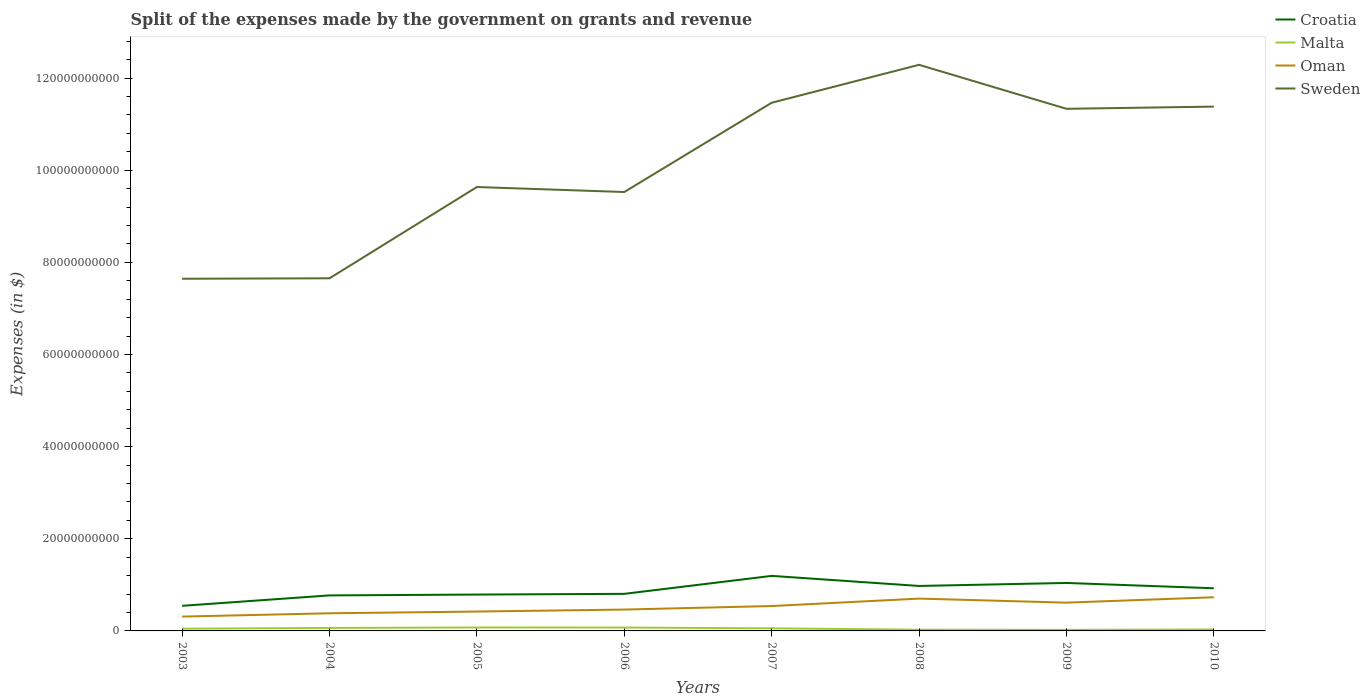How many different coloured lines are there?
Offer a very short reply. 4. Is the number of lines equal to the number of legend labels?
Ensure brevity in your answer.  Yes. Across all years, what is the maximum expenses made by the government on grants and revenue in Sweden?
Your answer should be very brief. 7.64e+1. In which year was the expenses made by the government on grants and revenue in Sweden maximum?
Offer a terse response. 2003. What is the total expenses made by the government on grants and revenue in Sweden in the graph?
Keep it short and to the point. -3.68e+1. What is the difference between the highest and the second highest expenses made by the government on grants and revenue in Croatia?
Keep it short and to the point. 6.50e+09. What is the difference between the highest and the lowest expenses made by the government on grants and revenue in Malta?
Make the answer very short. 4. How many years are there in the graph?
Provide a succinct answer. 8. Are the values on the major ticks of Y-axis written in scientific E-notation?
Provide a short and direct response. No. Does the graph contain any zero values?
Offer a terse response. No. Where does the legend appear in the graph?
Provide a short and direct response. Top right. How many legend labels are there?
Your response must be concise. 4. How are the legend labels stacked?
Your answer should be compact. Vertical. What is the title of the graph?
Your answer should be compact. Split of the expenses made by the government on grants and revenue. What is the label or title of the X-axis?
Offer a very short reply. Years. What is the label or title of the Y-axis?
Keep it short and to the point. Expenses (in $). What is the Expenses (in $) of Croatia in 2003?
Offer a terse response. 5.45e+09. What is the Expenses (in $) of Malta in 2003?
Make the answer very short. 4.88e+08. What is the Expenses (in $) of Oman in 2003?
Give a very brief answer. 3.11e+09. What is the Expenses (in $) of Sweden in 2003?
Your response must be concise. 7.64e+1. What is the Expenses (in $) of Croatia in 2004?
Your answer should be very brief. 7.71e+09. What is the Expenses (in $) in Malta in 2004?
Give a very brief answer. 6.48e+08. What is the Expenses (in $) in Oman in 2004?
Make the answer very short. 3.83e+09. What is the Expenses (in $) in Sweden in 2004?
Offer a terse response. 7.65e+1. What is the Expenses (in $) of Croatia in 2005?
Offer a very short reply. 7.89e+09. What is the Expenses (in $) in Malta in 2005?
Offer a very short reply. 7.45e+08. What is the Expenses (in $) of Oman in 2005?
Give a very brief answer. 4.21e+09. What is the Expenses (in $) in Sweden in 2005?
Offer a very short reply. 9.64e+1. What is the Expenses (in $) in Croatia in 2006?
Offer a terse response. 8.05e+09. What is the Expenses (in $) in Malta in 2006?
Offer a terse response. 7.33e+08. What is the Expenses (in $) in Oman in 2006?
Make the answer very short. 4.63e+09. What is the Expenses (in $) in Sweden in 2006?
Offer a very short reply. 9.53e+1. What is the Expenses (in $) of Croatia in 2007?
Provide a short and direct response. 1.19e+1. What is the Expenses (in $) of Malta in 2007?
Your answer should be compact. 5.64e+08. What is the Expenses (in $) in Oman in 2007?
Provide a succinct answer. 5.40e+09. What is the Expenses (in $) in Sweden in 2007?
Your response must be concise. 1.15e+11. What is the Expenses (in $) in Croatia in 2008?
Keep it short and to the point. 9.76e+09. What is the Expenses (in $) in Malta in 2008?
Ensure brevity in your answer.  2.65e+08. What is the Expenses (in $) of Oman in 2008?
Your response must be concise. 7.02e+09. What is the Expenses (in $) in Sweden in 2008?
Your answer should be very brief. 1.23e+11. What is the Expenses (in $) in Croatia in 2009?
Your response must be concise. 1.04e+1. What is the Expenses (in $) in Malta in 2009?
Offer a very short reply. 2.36e+08. What is the Expenses (in $) of Oman in 2009?
Your answer should be very brief. 6.14e+09. What is the Expenses (in $) in Sweden in 2009?
Provide a succinct answer. 1.13e+11. What is the Expenses (in $) of Croatia in 2010?
Provide a succinct answer. 9.26e+09. What is the Expenses (in $) in Malta in 2010?
Provide a succinct answer. 3.06e+08. What is the Expenses (in $) of Oman in 2010?
Offer a terse response. 7.31e+09. What is the Expenses (in $) in Sweden in 2010?
Offer a very short reply. 1.14e+11. Across all years, what is the maximum Expenses (in $) in Croatia?
Give a very brief answer. 1.19e+1. Across all years, what is the maximum Expenses (in $) in Malta?
Your answer should be compact. 7.45e+08. Across all years, what is the maximum Expenses (in $) of Oman?
Your answer should be very brief. 7.31e+09. Across all years, what is the maximum Expenses (in $) in Sweden?
Your response must be concise. 1.23e+11. Across all years, what is the minimum Expenses (in $) in Croatia?
Provide a short and direct response. 5.45e+09. Across all years, what is the minimum Expenses (in $) of Malta?
Ensure brevity in your answer.  2.36e+08. Across all years, what is the minimum Expenses (in $) of Oman?
Your answer should be very brief. 3.11e+09. Across all years, what is the minimum Expenses (in $) of Sweden?
Make the answer very short. 7.64e+1. What is the total Expenses (in $) in Croatia in the graph?
Offer a very short reply. 7.05e+1. What is the total Expenses (in $) of Malta in the graph?
Offer a very short reply. 3.98e+09. What is the total Expenses (in $) of Oman in the graph?
Keep it short and to the point. 4.16e+1. What is the total Expenses (in $) of Sweden in the graph?
Ensure brevity in your answer.  8.09e+11. What is the difference between the Expenses (in $) of Croatia in 2003 and that in 2004?
Your answer should be very brief. -2.26e+09. What is the difference between the Expenses (in $) of Malta in 2003 and that in 2004?
Offer a very short reply. -1.61e+08. What is the difference between the Expenses (in $) of Oman in 2003 and that in 2004?
Keep it short and to the point. -7.14e+08. What is the difference between the Expenses (in $) in Sweden in 2003 and that in 2004?
Give a very brief answer. -9.60e+07. What is the difference between the Expenses (in $) in Croatia in 2003 and that in 2005?
Give a very brief answer. -2.44e+09. What is the difference between the Expenses (in $) of Malta in 2003 and that in 2005?
Keep it short and to the point. -2.57e+08. What is the difference between the Expenses (in $) of Oman in 2003 and that in 2005?
Give a very brief answer. -1.09e+09. What is the difference between the Expenses (in $) in Sweden in 2003 and that in 2005?
Give a very brief answer. -1.99e+1. What is the difference between the Expenses (in $) of Croatia in 2003 and that in 2006?
Offer a terse response. -2.60e+09. What is the difference between the Expenses (in $) in Malta in 2003 and that in 2006?
Keep it short and to the point. -2.45e+08. What is the difference between the Expenses (in $) in Oman in 2003 and that in 2006?
Ensure brevity in your answer.  -1.52e+09. What is the difference between the Expenses (in $) of Sweden in 2003 and that in 2006?
Give a very brief answer. -1.88e+1. What is the difference between the Expenses (in $) of Croatia in 2003 and that in 2007?
Ensure brevity in your answer.  -6.50e+09. What is the difference between the Expenses (in $) in Malta in 2003 and that in 2007?
Make the answer very short. -7.63e+07. What is the difference between the Expenses (in $) of Oman in 2003 and that in 2007?
Your response must be concise. -2.29e+09. What is the difference between the Expenses (in $) in Sweden in 2003 and that in 2007?
Give a very brief answer. -3.82e+1. What is the difference between the Expenses (in $) of Croatia in 2003 and that in 2008?
Ensure brevity in your answer.  -4.31e+09. What is the difference between the Expenses (in $) in Malta in 2003 and that in 2008?
Your answer should be very brief. 2.23e+08. What is the difference between the Expenses (in $) in Oman in 2003 and that in 2008?
Your answer should be very brief. -3.90e+09. What is the difference between the Expenses (in $) of Sweden in 2003 and that in 2008?
Provide a succinct answer. -4.64e+1. What is the difference between the Expenses (in $) in Croatia in 2003 and that in 2009?
Make the answer very short. -4.96e+09. What is the difference between the Expenses (in $) of Malta in 2003 and that in 2009?
Provide a short and direct response. 2.52e+08. What is the difference between the Expenses (in $) of Oman in 2003 and that in 2009?
Your answer should be compact. -3.02e+09. What is the difference between the Expenses (in $) in Sweden in 2003 and that in 2009?
Ensure brevity in your answer.  -3.69e+1. What is the difference between the Expenses (in $) of Croatia in 2003 and that in 2010?
Offer a very short reply. -3.81e+09. What is the difference between the Expenses (in $) in Malta in 2003 and that in 2010?
Provide a succinct answer. 1.82e+08. What is the difference between the Expenses (in $) of Oman in 2003 and that in 2010?
Provide a short and direct response. -4.19e+09. What is the difference between the Expenses (in $) of Sweden in 2003 and that in 2010?
Provide a short and direct response. -3.74e+1. What is the difference between the Expenses (in $) in Croatia in 2004 and that in 2005?
Your answer should be compact. -1.84e+08. What is the difference between the Expenses (in $) in Malta in 2004 and that in 2005?
Make the answer very short. -9.64e+07. What is the difference between the Expenses (in $) of Oman in 2004 and that in 2005?
Provide a succinct answer. -3.76e+08. What is the difference between the Expenses (in $) in Sweden in 2004 and that in 2005?
Make the answer very short. -1.98e+1. What is the difference between the Expenses (in $) of Croatia in 2004 and that in 2006?
Keep it short and to the point. -3.39e+08. What is the difference between the Expenses (in $) in Malta in 2004 and that in 2006?
Offer a very short reply. -8.45e+07. What is the difference between the Expenses (in $) in Oman in 2004 and that in 2006?
Give a very brief answer. -8.06e+08. What is the difference between the Expenses (in $) of Sweden in 2004 and that in 2006?
Your answer should be compact. -1.87e+1. What is the difference between the Expenses (in $) of Croatia in 2004 and that in 2007?
Your answer should be very brief. -4.24e+09. What is the difference between the Expenses (in $) of Malta in 2004 and that in 2007?
Keep it short and to the point. 8.43e+07. What is the difference between the Expenses (in $) of Oman in 2004 and that in 2007?
Offer a terse response. -1.57e+09. What is the difference between the Expenses (in $) in Sweden in 2004 and that in 2007?
Your response must be concise. -3.81e+1. What is the difference between the Expenses (in $) in Croatia in 2004 and that in 2008?
Provide a short and direct response. -2.05e+09. What is the difference between the Expenses (in $) in Malta in 2004 and that in 2008?
Provide a short and direct response. 3.84e+08. What is the difference between the Expenses (in $) of Oman in 2004 and that in 2008?
Ensure brevity in your answer.  -3.19e+09. What is the difference between the Expenses (in $) in Sweden in 2004 and that in 2008?
Offer a terse response. -4.63e+1. What is the difference between the Expenses (in $) in Croatia in 2004 and that in 2009?
Provide a succinct answer. -2.71e+09. What is the difference between the Expenses (in $) in Malta in 2004 and that in 2009?
Your response must be concise. 4.12e+08. What is the difference between the Expenses (in $) in Oman in 2004 and that in 2009?
Your answer should be compact. -2.31e+09. What is the difference between the Expenses (in $) in Sweden in 2004 and that in 2009?
Ensure brevity in your answer.  -3.68e+1. What is the difference between the Expenses (in $) of Croatia in 2004 and that in 2010?
Offer a very short reply. -1.55e+09. What is the difference between the Expenses (in $) of Malta in 2004 and that in 2010?
Give a very brief answer. 3.43e+08. What is the difference between the Expenses (in $) of Oman in 2004 and that in 2010?
Provide a short and direct response. -3.48e+09. What is the difference between the Expenses (in $) in Sweden in 2004 and that in 2010?
Your response must be concise. -3.73e+1. What is the difference between the Expenses (in $) of Croatia in 2005 and that in 2006?
Keep it short and to the point. -1.55e+08. What is the difference between the Expenses (in $) of Malta in 2005 and that in 2006?
Make the answer very short. 1.19e+07. What is the difference between the Expenses (in $) of Oman in 2005 and that in 2006?
Make the answer very short. -4.30e+08. What is the difference between the Expenses (in $) in Sweden in 2005 and that in 2006?
Your answer should be very brief. 1.08e+09. What is the difference between the Expenses (in $) of Croatia in 2005 and that in 2007?
Keep it short and to the point. -4.06e+09. What is the difference between the Expenses (in $) of Malta in 2005 and that in 2007?
Your answer should be very brief. 1.81e+08. What is the difference between the Expenses (in $) of Oman in 2005 and that in 2007?
Give a very brief answer. -1.20e+09. What is the difference between the Expenses (in $) in Sweden in 2005 and that in 2007?
Provide a short and direct response. -1.83e+1. What is the difference between the Expenses (in $) in Croatia in 2005 and that in 2008?
Ensure brevity in your answer.  -1.87e+09. What is the difference between the Expenses (in $) in Malta in 2005 and that in 2008?
Make the answer very short. 4.80e+08. What is the difference between the Expenses (in $) of Oman in 2005 and that in 2008?
Give a very brief answer. -2.81e+09. What is the difference between the Expenses (in $) in Sweden in 2005 and that in 2008?
Offer a very short reply. -2.65e+1. What is the difference between the Expenses (in $) in Croatia in 2005 and that in 2009?
Your response must be concise. -2.52e+09. What is the difference between the Expenses (in $) in Malta in 2005 and that in 2009?
Make the answer very short. 5.09e+08. What is the difference between the Expenses (in $) in Oman in 2005 and that in 2009?
Your answer should be compact. -1.93e+09. What is the difference between the Expenses (in $) in Sweden in 2005 and that in 2009?
Make the answer very short. -1.70e+1. What is the difference between the Expenses (in $) in Croatia in 2005 and that in 2010?
Make the answer very short. -1.37e+09. What is the difference between the Expenses (in $) of Malta in 2005 and that in 2010?
Your response must be concise. 4.39e+08. What is the difference between the Expenses (in $) of Oman in 2005 and that in 2010?
Make the answer very short. -3.10e+09. What is the difference between the Expenses (in $) of Sweden in 2005 and that in 2010?
Your response must be concise. -1.75e+1. What is the difference between the Expenses (in $) in Croatia in 2006 and that in 2007?
Make the answer very short. -3.90e+09. What is the difference between the Expenses (in $) in Malta in 2006 and that in 2007?
Provide a short and direct response. 1.69e+08. What is the difference between the Expenses (in $) in Oman in 2006 and that in 2007?
Give a very brief answer. -7.66e+08. What is the difference between the Expenses (in $) of Sweden in 2006 and that in 2007?
Your answer should be compact. -1.94e+1. What is the difference between the Expenses (in $) of Croatia in 2006 and that in 2008?
Provide a short and direct response. -1.71e+09. What is the difference between the Expenses (in $) of Malta in 2006 and that in 2008?
Make the answer very short. 4.68e+08. What is the difference between the Expenses (in $) of Oman in 2006 and that in 2008?
Ensure brevity in your answer.  -2.38e+09. What is the difference between the Expenses (in $) of Sweden in 2006 and that in 2008?
Your response must be concise. -2.76e+1. What is the difference between the Expenses (in $) of Croatia in 2006 and that in 2009?
Provide a succinct answer. -2.37e+09. What is the difference between the Expenses (in $) of Malta in 2006 and that in 2009?
Keep it short and to the point. 4.97e+08. What is the difference between the Expenses (in $) of Oman in 2006 and that in 2009?
Provide a short and direct response. -1.50e+09. What is the difference between the Expenses (in $) of Sweden in 2006 and that in 2009?
Ensure brevity in your answer.  -1.81e+1. What is the difference between the Expenses (in $) in Croatia in 2006 and that in 2010?
Your response must be concise. -1.22e+09. What is the difference between the Expenses (in $) of Malta in 2006 and that in 2010?
Your answer should be compact. 4.27e+08. What is the difference between the Expenses (in $) of Oman in 2006 and that in 2010?
Provide a succinct answer. -2.67e+09. What is the difference between the Expenses (in $) of Sweden in 2006 and that in 2010?
Keep it short and to the point. -1.85e+1. What is the difference between the Expenses (in $) in Croatia in 2007 and that in 2008?
Provide a succinct answer. 2.19e+09. What is the difference between the Expenses (in $) in Malta in 2007 and that in 2008?
Your answer should be compact. 3.00e+08. What is the difference between the Expenses (in $) in Oman in 2007 and that in 2008?
Provide a succinct answer. -1.62e+09. What is the difference between the Expenses (in $) in Sweden in 2007 and that in 2008?
Your answer should be very brief. -8.23e+09. What is the difference between the Expenses (in $) in Croatia in 2007 and that in 2009?
Offer a very short reply. 1.53e+09. What is the difference between the Expenses (in $) in Malta in 2007 and that in 2009?
Offer a terse response. 3.28e+08. What is the difference between the Expenses (in $) of Oman in 2007 and that in 2009?
Provide a succinct answer. -7.37e+08. What is the difference between the Expenses (in $) of Sweden in 2007 and that in 2009?
Provide a succinct answer. 1.31e+09. What is the difference between the Expenses (in $) of Croatia in 2007 and that in 2010?
Provide a succinct answer. 2.69e+09. What is the difference between the Expenses (in $) of Malta in 2007 and that in 2010?
Provide a short and direct response. 2.58e+08. What is the difference between the Expenses (in $) in Oman in 2007 and that in 2010?
Keep it short and to the point. -1.90e+09. What is the difference between the Expenses (in $) in Sweden in 2007 and that in 2010?
Offer a terse response. 8.37e+08. What is the difference between the Expenses (in $) in Croatia in 2008 and that in 2009?
Your response must be concise. -6.52e+08. What is the difference between the Expenses (in $) of Malta in 2008 and that in 2009?
Your answer should be compact. 2.85e+07. What is the difference between the Expenses (in $) in Oman in 2008 and that in 2009?
Offer a terse response. 8.79e+08. What is the difference between the Expenses (in $) in Sweden in 2008 and that in 2009?
Make the answer very short. 9.54e+09. What is the difference between the Expenses (in $) in Croatia in 2008 and that in 2010?
Your answer should be compact. 4.98e+08. What is the difference between the Expenses (in $) in Malta in 2008 and that in 2010?
Keep it short and to the point. -4.12e+07. What is the difference between the Expenses (in $) in Oman in 2008 and that in 2010?
Make the answer very short. -2.88e+08. What is the difference between the Expenses (in $) in Sweden in 2008 and that in 2010?
Offer a very short reply. 9.07e+09. What is the difference between the Expenses (in $) in Croatia in 2009 and that in 2010?
Your response must be concise. 1.15e+09. What is the difference between the Expenses (in $) in Malta in 2009 and that in 2010?
Offer a very short reply. -6.97e+07. What is the difference between the Expenses (in $) of Oman in 2009 and that in 2010?
Offer a very short reply. -1.17e+09. What is the difference between the Expenses (in $) of Sweden in 2009 and that in 2010?
Offer a very short reply. -4.74e+08. What is the difference between the Expenses (in $) in Croatia in 2003 and the Expenses (in $) in Malta in 2004?
Keep it short and to the point. 4.80e+09. What is the difference between the Expenses (in $) in Croatia in 2003 and the Expenses (in $) in Oman in 2004?
Provide a short and direct response. 1.62e+09. What is the difference between the Expenses (in $) of Croatia in 2003 and the Expenses (in $) of Sweden in 2004?
Ensure brevity in your answer.  -7.11e+1. What is the difference between the Expenses (in $) in Malta in 2003 and the Expenses (in $) in Oman in 2004?
Your answer should be very brief. -3.34e+09. What is the difference between the Expenses (in $) of Malta in 2003 and the Expenses (in $) of Sweden in 2004?
Offer a very short reply. -7.61e+1. What is the difference between the Expenses (in $) of Oman in 2003 and the Expenses (in $) of Sweden in 2004?
Provide a short and direct response. -7.34e+1. What is the difference between the Expenses (in $) in Croatia in 2003 and the Expenses (in $) in Malta in 2005?
Make the answer very short. 4.70e+09. What is the difference between the Expenses (in $) of Croatia in 2003 and the Expenses (in $) of Oman in 2005?
Give a very brief answer. 1.24e+09. What is the difference between the Expenses (in $) in Croatia in 2003 and the Expenses (in $) in Sweden in 2005?
Your answer should be very brief. -9.09e+1. What is the difference between the Expenses (in $) in Malta in 2003 and the Expenses (in $) in Oman in 2005?
Your answer should be compact. -3.72e+09. What is the difference between the Expenses (in $) in Malta in 2003 and the Expenses (in $) in Sweden in 2005?
Offer a very short reply. -9.59e+1. What is the difference between the Expenses (in $) of Oman in 2003 and the Expenses (in $) of Sweden in 2005?
Your answer should be very brief. -9.32e+1. What is the difference between the Expenses (in $) in Croatia in 2003 and the Expenses (in $) in Malta in 2006?
Provide a short and direct response. 4.72e+09. What is the difference between the Expenses (in $) of Croatia in 2003 and the Expenses (in $) of Oman in 2006?
Keep it short and to the point. 8.15e+08. What is the difference between the Expenses (in $) of Croatia in 2003 and the Expenses (in $) of Sweden in 2006?
Ensure brevity in your answer.  -8.98e+1. What is the difference between the Expenses (in $) of Malta in 2003 and the Expenses (in $) of Oman in 2006?
Offer a terse response. -4.15e+09. What is the difference between the Expenses (in $) of Malta in 2003 and the Expenses (in $) of Sweden in 2006?
Provide a short and direct response. -9.48e+1. What is the difference between the Expenses (in $) in Oman in 2003 and the Expenses (in $) in Sweden in 2006?
Make the answer very short. -9.22e+1. What is the difference between the Expenses (in $) of Croatia in 2003 and the Expenses (in $) of Malta in 2007?
Your answer should be very brief. 4.89e+09. What is the difference between the Expenses (in $) of Croatia in 2003 and the Expenses (in $) of Oman in 2007?
Ensure brevity in your answer.  4.87e+07. What is the difference between the Expenses (in $) in Croatia in 2003 and the Expenses (in $) in Sweden in 2007?
Your answer should be compact. -1.09e+11. What is the difference between the Expenses (in $) of Malta in 2003 and the Expenses (in $) of Oman in 2007?
Ensure brevity in your answer.  -4.91e+09. What is the difference between the Expenses (in $) of Malta in 2003 and the Expenses (in $) of Sweden in 2007?
Provide a short and direct response. -1.14e+11. What is the difference between the Expenses (in $) of Oman in 2003 and the Expenses (in $) of Sweden in 2007?
Ensure brevity in your answer.  -1.12e+11. What is the difference between the Expenses (in $) of Croatia in 2003 and the Expenses (in $) of Malta in 2008?
Keep it short and to the point. 5.19e+09. What is the difference between the Expenses (in $) in Croatia in 2003 and the Expenses (in $) in Oman in 2008?
Make the answer very short. -1.57e+09. What is the difference between the Expenses (in $) of Croatia in 2003 and the Expenses (in $) of Sweden in 2008?
Provide a succinct answer. -1.17e+11. What is the difference between the Expenses (in $) of Malta in 2003 and the Expenses (in $) of Oman in 2008?
Your answer should be very brief. -6.53e+09. What is the difference between the Expenses (in $) of Malta in 2003 and the Expenses (in $) of Sweden in 2008?
Give a very brief answer. -1.22e+11. What is the difference between the Expenses (in $) of Oman in 2003 and the Expenses (in $) of Sweden in 2008?
Keep it short and to the point. -1.20e+11. What is the difference between the Expenses (in $) in Croatia in 2003 and the Expenses (in $) in Malta in 2009?
Your answer should be very brief. 5.21e+09. What is the difference between the Expenses (in $) in Croatia in 2003 and the Expenses (in $) in Oman in 2009?
Offer a terse response. -6.89e+08. What is the difference between the Expenses (in $) of Croatia in 2003 and the Expenses (in $) of Sweden in 2009?
Make the answer very short. -1.08e+11. What is the difference between the Expenses (in $) in Malta in 2003 and the Expenses (in $) in Oman in 2009?
Provide a succinct answer. -5.65e+09. What is the difference between the Expenses (in $) of Malta in 2003 and the Expenses (in $) of Sweden in 2009?
Your response must be concise. -1.13e+11. What is the difference between the Expenses (in $) in Oman in 2003 and the Expenses (in $) in Sweden in 2009?
Keep it short and to the point. -1.10e+11. What is the difference between the Expenses (in $) in Croatia in 2003 and the Expenses (in $) in Malta in 2010?
Give a very brief answer. 5.14e+09. What is the difference between the Expenses (in $) of Croatia in 2003 and the Expenses (in $) of Oman in 2010?
Offer a very short reply. -1.86e+09. What is the difference between the Expenses (in $) in Croatia in 2003 and the Expenses (in $) in Sweden in 2010?
Your answer should be very brief. -1.08e+11. What is the difference between the Expenses (in $) in Malta in 2003 and the Expenses (in $) in Oman in 2010?
Provide a succinct answer. -6.82e+09. What is the difference between the Expenses (in $) of Malta in 2003 and the Expenses (in $) of Sweden in 2010?
Offer a terse response. -1.13e+11. What is the difference between the Expenses (in $) of Oman in 2003 and the Expenses (in $) of Sweden in 2010?
Keep it short and to the point. -1.11e+11. What is the difference between the Expenses (in $) in Croatia in 2004 and the Expenses (in $) in Malta in 2005?
Your answer should be compact. 6.96e+09. What is the difference between the Expenses (in $) of Croatia in 2004 and the Expenses (in $) of Oman in 2005?
Offer a terse response. 3.50e+09. What is the difference between the Expenses (in $) in Croatia in 2004 and the Expenses (in $) in Sweden in 2005?
Provide a succinct answer. -8.86e+1. What is the difference between the Expenses (in $) in Malta in 2004 and the Expenses (in $) in Oman in 2005?
Offer a terse response. -3.56e+09. What is the difference between the Expenses (in $) in Malta in 2004 and the Expenses (in $) in Sweden in 2005?
Your response must be concise. -9.57e+1. What is the difference between the Expenses (in $) in Oman in 2004 and the Expenses (in $) in Sweden in 2005?
Your response must be concise. -9.25e+1. What is the difference between the Expenses (in $) of Croatia in 2004 and the Expenses (in $) of Malta in 2006?
Your answer should be very brief. 6.98e+09. What is the difference between the Expenses (in $) in Croatia in 2004 and the Expenses (in $) in Oman in 2006?
Provide a succinct answer. 3.07e+09. What is the difference between the Expenses (in $) in Croatia in 2004 and the Expenses (in $) in Sweden in 2006?
Give a very brief answer. -8.76e+1. What is the difference between the Expenses (in $) of Malta in 2004 and the Expenses (in $) of Oman in 2006?
Keep it short and to the point. -3.99e+09. What is the difference between the Expenses (in $) in Malta in 2004 and the Expenses (in $) in Sweden in 2006?
Your response must be concise. -9.46e+1. What is the difference between the Expenses (in $) of Oman in 2004 and the Expenses (in $) of Sweden in 2006?
Offer a terse response. -9.14e+1. What is the difference between the Expenses (in $) in Croatia in 2004 and the Expenses (in $) in Malta in 2007?
Provide a succinct answer. 7.14e+09. What is the difference between the Expenses (in $) in Croatia in 2004 and the Expenses (in $) in Oman in 2007?
Your answer should be very brief. 2.31e+09. What is the difference between the Expenses (in $) in Croatia in 2004 and the Expenses (in $) in Sweden in 2007?
Give a very brief answer. -1.07e+11. What is the difference between the Expenses (in $) of Malta in 2004 and the Expenses (in $) of Oman in 2007?
Your answer should be very brief. -4.75e+09. What is the difference between the Expenses (in $) in Malta in 2004 and the Expenses (in $) in Sweden in 2007?
Ensure brevity in your answer.  -1.14e+11. What is the difference between the Expenses (in $) in Oman in 2004 and the Expenses (in $) in Sweden in 2007?
Make the answer very short. -1.11e+11. What is the difference between the Expenses (in $) of Croatia in 2004 and the Expenses (in $) of Malta in 2008?
Provide a succinct answer. 7.44e+09. What is the difference between the Expenses (in $) in Croatia in 2004 and the Expenses (in $) in Oman in 2008?
Ensure brevity in your answer.  6.90e+08. What is the difference between the Expenses (in $) in Croatia in 2004 and the Expenses (in $) in Sweden in 2008?
Provide a succinct answer. -1.15e+11. What is the difference between the Expenses (in $) in Malta in 2004 and the Expenses (in $) in Oman in 2008?
Offer a very short reply. -6.37e+09. What is the difference between the Expenses (in $) in Malta in 2004 and the Expenses (in $) in Sweden in 2008?
Your response must be concise. -1.22e+11. What is the difference between the Expenses (in $) in Oman in 2004 and the Expenses (in $) in Sweden in 2008?
Your answer should be compact. -1.19e+11. What is the difference between the Expenses (in $) of Croatia in 2004 and the Expenses (in $) of Malta in 2009?
Give a very brief answer. 7.47e+09. What is the difference between the Expenses (in $) in Croatia in 2004 and the Expenses (in $) in Oman in 2009?
Offer a terse response. 1.57e+09. What is the difference between the Expenses (in $) of Croatia in 2004 and the Expenses (in $) of Sweden in 2009?
Keep it short and to the point. -1.06e+11. What is the difference between the Expenses (in $) of Malta in 2004 and the Expenses (in $) of Oman in 2009?
Ensure brevity in your answer.  -5.49e+09. What is the difference between the Expenses (in $) of Malta in 2004 and the Expenses (in $) of Sweden in 2009?
Provide a short and direct response. -1.13e+11. What is the difference between the Expenses (in $) of Oman in 2004 and the Expenses (in $) of Sweden in 2009?
Your response must be concise. -1.10e+11. What is the difference between the Expenses (in $) of Croatia in 2004 and the Expenses (in $) of Malta in 2010?
Give a very brief answer. 7.40e+09. What is the difference between the Expenses (in $) in Croatia in 2004 and the Expenses (in $) in Oman in 2010?
Keep it short and to the point. 4.03e+08. What is the difference between the Expenses (in $) in Croatia in 2004 and the Expenses (in $) in Sweden in 2010?
Your answer should be compact. -1.06e+11. What is the difference between the Expenses (in $) of Malta in 2004 and the Expenses (in $) of Oman in 2010?
Provide a short and direct response. -6.66e+09. What is the difference between the Expenses (in $) in Malta in 2004 and the Expenses (in $) in Sweden in 2010?
Give a very brief answer. -1.13e+11. What is the difference between the Expenses (in $) in Oman in 2004 and the Expenses (in $) in Sweden in 2010?
Keep it short and to the point. -1.10e+11. What is the difference between the Expenses (in $) in Croatia in 2005 and the Expenses (in $) in Malta in 2006?
Ensure brevity in your answer.  7.16e+09. What is the difference between the Expenses (in $) in Croatia in 2005 and the Expenses (in $) in Oman in 2006?
Provide a short and direct response. 3.26e+09. What is the difference between the Expenses (in $) of Croatia in 2005 and the Expenses (in $) of Sweden in 2006?
Your response must be concise. -8.74e+1. What is the difference between the Expenses (in $) of Malta in 2005 and the Expenses (in $) of Oman in 2006?
Make the answer very short. -3.89e+09. What is the difference between the Expenses (in $) of Malta in 2005 and the Expenses (in $) of Sweden in 2006?
Ensure brevity in your answer.  -9.45e+1. What is the difference between the Expenses (in $) of Oman in 2005 and the Expenses (in $) of Sweden in 2006?
Your answer should be very brief. -9.11e+1. What is the difference between the Expenses (in $) in Croatia in 2005 and the Expenses (in $) in Malta in 2007?
Give a very brief answer. 7.33e+09. What is the difference between the Expenses (in $) in Croatia in 2005 and the Expenses (in $) in Oman in 2007?
Give a very brief answer. 2.49e+09. What is the difference between the Expenses (in $) in Croatia in 2005 and the Expenses (in $) in Sweden in 2007?
Ensure brevity in your answer.  -1.07e+11. What is the difference between the Expenses (in $) of Malta in 2005 and the Expenses (in $) of Oman in 2007?
Offer a very short reply. -4.66e+09. What is the difference between the Expenses (in $) in Malta in 2005 and the Expenses (in $) in Sweden in 2007?
Offer a very short reply. -1.14e+11. What is the difference between the Expenses (in $) in Oman in 2005 and the Expenses (in $) in Sweden in 2007?
Your answer should be very brief. -1.10e+11. What is the difference between the Expenses (in $) of Croatia in 2005 and the Expenses (in $) of Malta in 2008?
Provide a succinct answer. 7.63e+09. What is the difference between the Expenses (in $) of Croatia in 2005 and the Expenses (in $) of Oman in 2008?
Keep it short and to the point. 8.74e+08. What is the difference between the Expenses (in $) in Croatia in 2005 and the Expenses (in $) in Sweden in 2008?
Your answer should be compact. -1.15e+11. What is the difference between the Expenses (in $) of Malta in 2005 and the Expenses (in $) of Oman in 2008?
Provide a succinct answer. -6.27e+09. What is the difference between the Expenses (in $) in Malta in 2005 and the Expenses (in $) in Sweden in 2008?
Ensure brevity in your answer.  -1.22e+11. What is the difference between the Expenses (in $) of Oman in 2005 and the Expenses (in $) of Sweden in 2008?
Keep it short and to the point. -1.19e+11. What is the difference between the Expenses (in $) in Croatia in 2005 and the Expenses (in $) in Malta in 2009?
Keep it short and to the point. 7.66e+09. What is the difference between the Expenses (in $) in Croatia in 2005 and the Expenses (in $) in Oman in 2009?
Make the answer very short. 1.75e+09. What is the difference between the Expenses (in $) of Croatia in 2005 and the Expenses (in $) of Sweden in 2009?
Your answer should be compact. -1.05e+11. What is the difference between the Expenses (in $) of Malta in 2005 and the Expenses (in $) of Oman in 2009?
Your response must be concise. -5.39e+09. What is the difference between the Expenses (in $) in Malta in 2005 and the Expenses (in $) in Sweden in 2009?
Your response must be concise. -1.13e+11. What is the difference between the Expenses (in $) in Oman in 2005 and the Expenses (in $) in Sweden in 2009?
Give a very brief answer. -1.09e+11. What is the difference between the Expenses (in $) in Croatia in 2005 and the Expenses (in $) in Malta in 2010?
Give a very brief answer. 7.59e+09. What is the difference between the Expenses (in $) of Croatia in 2005 and the Expenses (in $) of Oman in 2010?
Your response must be concise. 5.87e+08. What is the difference between the Expenses (in $) of Croatia in 2005 and the Expenses (in $) of Sweden in 2010?
Your response must be concise. -1.06e+11. What is the difference between the Expenses (in $) of Malta in 2005 and the Expenses (in $) of Oman in 2010?
Your answer should be very brief. -6.56e+09. What is the difference between the Expenses (in $) in Malta in 2005 and the Expenses (in $) in Sweden in 2010?
Your answer should be very brief. -1.13e+11. What is the difference between the Expenses (in $) of Oman in 2005 and the Expenses (in $) of Sweden in 2010?
Your response must be concise. -1.10e+11. What is the difference between the Expenses (in $) of Croatia in 2006 and the Expenses (in $) of Malta in 2007?
Give a very brief answer. 7.48e+09. What is the difference between the Expenses (in $) of Croatia in 2006 and the Expenses (in $) of Oman in 2007?
Offer a terse response. 2.65e+09. What is the difference between the Expenses (in $) of Croatia in 2006 and the Expenses (in $) of Sweden in 2007?
Make the answer very short. -1.07e+11. What is the difference between the Expenses (in $) of Malta in 2006 and the Expenses (in $) of Oman in 2007?
Your answer should be very brief. -4.67e+09. What is the difference between the Expenses (in $) of Malta in 2006 and the Expenses (in $) of Sweden in 2007?
Provide a succinct answer. -1.14e+11. What is the difference between the Expenses (in $) of Oman in 2006 and the Expenses (in $) of Sweden in 2007?
Your response must be concise. -1.10e+11. What is the difference between the Expenses (in $) in Croatia in 2006 and the Expenses (in $) in Malta in 2008?
Keep it short and to the point. 7.78e+09. What is the difference between the Expenses (in $) of Croatia in 2006 and the Expenses (in $) of Oman in 2008?
Your answer should be compact. 1.03e+09. What is the difference between the Expenses (in $) in Croatia in 2006 and the Expenses (in $) in Sweden in 2008?
Make the answer very short. -1.15e+11. What is the difference between the Expenses (in $) in Malta in 2006 and the Expenses (in $) in Oman in 2008?
Keep it short and to the point. -6.28e+09. What is the difference between the Expenses (in $) of Malta in 2006 and the Expenses (in $) of Sweden in 2008?
Ensure brevity in your answer.  -1.22e+11. What is the difference between the Expenses (in $) in Oman in 2006 and the Expenses (in $) in Sweden in 2008?
Keep it short and to the point. -1.18e+11. What is the difference between the Expenses (in $) in Croatia in 2006 and the Expenses (in $) in Malta in 2009?
Provide a succinct answer. 7.81e+09. What is the difference between the Expenses (in $) of Croatia in 2006 and the Expenses (in $) of Oman in 2009?
Your answer should be compact. 1.91e+09. What is the difference between the Expenses (in $) in Croatia in 2006 and the Expenses (in $) in Sweden in 2009?
Your response must be concise. -1.05e+11. What is the difference between the Expenses (in $) in Malta in 2006 and the Expenses (in $) in Oman in 2009?
Offer a very short reply. -5.41e+09. What is the difference between the Expenses (in $) in Malta in 2006 and the Expenses (in $) in Sweden in 2009?
Provide a short and direct response. -1.13e+11. What is the difference between the Expenses (in $) of Oman in 2006 and the Expenses (in $) of Sweden in 2009?
Keep it short and to the point. -1.09e+11. What is the difference between the Expenses (in $) in Croatia in 2006 and the Expenses (in $) in Malta in 2010?
Provide a succinct answer. 7.74e+09. What is the difference between the Expenses (in $) in Croatia in 2006 and the Expenses (in $) in Oman in 2010?
Give a very brief answer. 7.42e+08. What is the difference between the Expenses (in $) of Croatia in 2006 and the Expenses (in $) of Sweden in 2010?
Your response must be concise. -1.06e+11. What is the difference between the Expenses (in $) in Malta in 2006 and the Expenses (in $) in Oman in 2010?
Your response must be concise. -6.57e+09. What is the difference between the Expenses (in $) of Malta in 2006 and the Expenses (in $) of Sweden in 2010?
Your answer should be compact. -1.13e+11. What is the difference between the Expenses (in $) of Oman in 2006 and the Expenses (in $) of Sweden in 2010?
Provide a succinct answer. -1.09e+11. What is the difference between the Expenses (in $) of Croatia in 2007 and the Expenses (in $) of Malta in 2008?
Your answer should be compact. 1.17e+1. What is the difference between the Expenses (in $) in Croatia in 2007 and the Expenses (in $) in Oman in 2008?
Your answer should be very brief. 4.93e+09. What is the difference between the Expenses (in $) in Croatia in 2007 and the Expenses (in $) in Sweden in 2008?
Your answer should be very brief. -1.11e+11. What is the difference between the Expenses (in $) in Malta in 2007 and the Expenses (in $) in Oman in 2008?
Offer a terse response. -6.45e+09. What is the difference between the Expenses (in $) in Malta in 2007 and the Expenses (in $) in Sweden in 2008?
Keep it short and to the point. -1.22e+11. What is the difference between the Expenses (in $) of Oman in 2007 and the Expenses (in $) of Sweden in 2008?
Keep it short and to the point. -1.17e+11. What is the difference between the Expenses (in $) in Croatia in 2007 and the Expenses (in $) in Malta in 2009?
Offer a very short reply. 1.17e+1. What is the difference between the Expenses (in $) of Croatia in 2007 and the Expenses (in $) of Oman in 2009?
Ensure brevity in your answer.  5.81e+09. What is the difference between the Expenses (in $) of Croatia in 2007 and the Expenses (in $) of Sweden in 2009?
Offer a very short reply. -1.01e+11. What is the difference between the Expenses (in $) of Malta in 2007 and the Expenses (in $) of Oman in 2009?
Give a very brief answer. -5.57e+09. What is the difference between the Expenses (in $) in Malta in 2007 and the Expenses (in $) in Sweden in 2009?
Keep it short and to the point. -1.13e+11. What is the difference between the Expenses (in $) in Oman in 2007 and the Expenses (in $) in Sweden in 2009?
Provide a succinct answer. -1.08e+11. What is the difference between the Expenses (in $) in Croatia in 2007 and the Expenses (in $) in Malta in 2010?
Your answer should be very brief. 1.16e+1. What is the difference between the Expenses (in $) of Croatia in 2007 and the Expenses (in $) of Oman in 2010?
Give a very brief answer. 4.64e+09. What is the difference between the Expenses (in $) in Croatia in 2007 and the Expenses (in $) in Sweden in 2010?
Offer a very short reply. -1.02e+11. What is the difference between the Expenses (in $) of Malta in 2007 and the Expenses (in $) of Oman in 2010?
Provide a short and direct response. -6.74e+09. What is the difference between the Expenses (in $) in Malta in 2007 and the Expenses (in $) in Sweden in 2010?
Give a very brief answer. -1.13e+11. What is the difference between the Expenses (in $) of Oman in 2007 and the Expenses (in $) of Sweden in 2010?
Provide a succinct answer. -1.08e+11. What is the difference between the Expenses (in $) of Croatia in 2008 and the Expenses (in $) of Malta in 2009?
Provide a succinct answer. 9.52e+09. What is the difference between the Expenses (in $) in Croatia in 2008 and the Expenses (in $) in Oman in 2009?
Make the answer very short. 3.62e+09. What is the difference between the Expenses (in $) in Croatia in 2008 and the Expenses (in $) in Sweden in 2009?
Your answer should be compact. -1.04e+11. What is the difference between the Expenses (in $) in Malta in 2008 and the Expenses (in $) in Oman in 2009?
Give a very brief answer. -5.87e+09. What is the difference between the Expenses (in $) of Malta in 2008 and the Expenses (in $) of Sweden in 2009?
Make the answer very short. -1.13e+11. What is the difference between the Expenses (in $) of Oman in 2008 and the Expenses (in $) of Sweden in 2009?
Provide a succinct answer. -1.06e+11. What is the difference between the Expenses (in $) in Croatia in 2008 and the Expenses (in $) in Malta in 2010?
Make the answer very short. 9.46e+09. What is the difference between the Expenses (in $) of Croatia in 2008 and the Expenses (in $) of Oman in 2010?
Your answer should be very brief. 2.46e+09. What is the difference between the Expenses (in $) in Croatia in 2008 and the Expenses (in $) in Sweden in 2010?
Provide a short and direct response. -1.04e+11. What is the difference between the Expenses (in $) in Malta in 2008 and the Expenses (in $) in Oman in 2010?
Keep it short and to the point. -7.04e+09. What is the difference between the Expenses (in $) in Malta in 2008 and the Expenses (in $) in Sweden in 2010?
Your response must be concise. -1.14e+11. What is the difference between the Expenses (in $) of Oman in 2008 and the Expenses (in $) of Sweden in 2010?
Ensure brevity in your answer.  -1.07e+11. What is the difference between the Expenses (in $) of Croatia in 2009 and the Expenses (in $) of Malta in 2010?
Offer a very short reply. 1.01e+1. What is the difference between the Expenses (in $) of Croatia in 2009 and the Expenses (in $) of Oman in 2010?
Provide a short and direct response. 3.11e+09. What is the difference between the Expenses (in $) in Croatia in 2009 and the Expenses (in $) in Sweden in 2010?
Give a very brief answer. -1.03e+11. What is the difference between the Expenses (in $) of Malta in 2009 and the Expenses (in $) of Oman in 2010?
Provide a succinct answer. -7.07e+09. What is the difference between the Expenses (in $) of Malta in 2009 and the Expenses (in $) of Sweden in 2010?
Your response must be concise. -1.14e+11. What is the difference between the Expenses (in $) of Oman in 2009 and the Expenses (in $) of Sweden in 2010?
Provide a succinct answer. -1.08e+11. What is the average Expenses (in $) in Croatia per year?
Your response must be concise. 8.81e+09. What is the average Expenses (in $) in Malta per year?
Your response must be concise. 4.98e+08. What is the average Expenses (in $) in Oman per year?
Keep it short and to the point. 5.21e+09. What is the average Expenses (in $) of Sweden per year?
Offer a terse response. 1.01e+11. In the year 2003, what is the difference between the Expenses (in $) of Croatia and Expenses (in $) of Malta?
Offer a terse response. 4.96e+09. In the year 2003, what is the difference between the Expenses (in $) of Croatia and Expenses (in $) of Oman?
Keep it short and to the point. 2.34e+09. In the year 2003, what is the difference between the Expenses (in $) of Croatia and Expenses (in $) of Sweden?
Your answer should be very brief. -7.10e+1. In the year 2003, what is the difference between the Expenses (in $) of Malta and Expenses (in $) of Oman?
Keep it short and to the point. -2.63e+09. In the year 2003, what is the difference between the Expenses (in $) in Malta and Expenses (in $) in Sweden?
Your answer should be very brief. -7.60e+1. In the year 2003, what is the difference between the Expenses (in $) in Oman and Expenses (in $) in Sweden?
Provide a short and direct response. -7.33e+1. In the year 2004, what is the difference between the Expenses (in $) of Croatia and Expenses (in $) of Malta?
Your answer should be compact. 7.06e+09. In the year 2004, what is the difference between the Expenses (in $) in Croatia and Expenses (in $) in Oman?
Your response must be concise. 3.88e+09. In the year 2004, what is the difference between the Expenses (in $) of Croatia and Expenses (in $) of Sweden?
Your response must be concise. -6.88e+1. In the year 2004, what is the difference between the Expenses (in $) in Malta and Expenses (in $) in Oman?
Provide a succinct answer. -3.18e+09. In the year 2004, what is the difference between the Expenses (in $) of Malta and Expenses (in $) of Sweden?
Your response must be concise. -7.59e+1. In the year 2004, what is the difference between the Expenses (in $) of Oman and Expenses (in $) of Sweden?
Offer a terse response. -7.27e+1. In the year 2005, what is the difference between the Expenses (in $) in Croatia and Expenses (in $) in Malta?
Make the answer very short. 7.15e+09. In the year 2005, what is the difference between the Expenses (in $) of Croatia and Expenses (in $) of Oman?
Provide a succinct answer. 3.69e+09. In the year 2005, what is the difference between the Expenses (in $) of Croatia and Expenses (in $) of Sweden?
Your answer should be compact. -8.85e+1. In the year 2005, what is the difference between the Expenses (in $) in Malta and Expenses (in $) in Oman?
Keep it short and to the point. -3.46e+09. In the year 2005, what is the difference between the Expenses (in $) of Malta and Expenses (in $) of Sweden?
Your answer should be very brief. -9.56e+1. In the year 2005, what is the difference between the Expenses (in $) of Oman and Expenses (in $) of Sweden?
Your answer should be very brief. -9.21e+1. In the year 2006, what is the difference between the Expenses (in $) in Croatia and Expenses (in $) in Malta?
Ensure brevity in your answer.  7.31e+09. In the year 2006, what is the difference between the Expenses (in $) of Croatia and Expenses (in $) of Oman?
Ensure brevity in your answer.  3.41e+09. In the year 2006, what is the difference between the Expenses (in $) in Croatia and Expenses (in $) in Sweden?
Your response must be concise. -8.72e+1. In the year 2006, what is the difference between the Expenses (in $) in Malta and Expenses (in $) in Oman?
Offer a very short reply. -3.90e+09. In the year 2006, what is the difference between the Expenses (in $) in Malta and Expenses (in $) in Sweden?
Provide a short and direct response. -9.45e+1. In the year 2006, what is the difference between the Expenses (in $) of Oman and Expenses (in $) of Sweden?
Your answer should be compact. -9.06e+1. In the year 2007, what is the difference between the Expenses (in $) in Croatia and Expenses (in $) in Malta?
Offer a terse response. 1.14e+1. In the year 2007, what is the difference between the Expenses (in $) of Croatia and Expenses (in $) of Oman?
Your answer should be compact. 6.55e+09. In the year 2007, what is the difference between the Expenses (in $) in Croatia and Expenses (in $) in Sweden?
Your answer should be very brief. -1.03e+11. In the year 2007, what is the difference between the Expenses (in $) of Malta and Expenses (in $) of Oman?
Offer a very short reply. -4.84e+09. In the year 2007, what is the difference between the Expenses (in $) in Malta and Expenses (in $) in Sweden?
Give a very brief answer. -1.14e+11. In the year 2007, what is the difference between the Expenses (in $) of Oman and Expenses (in $) of Sweden?
Make the answer very short. -1.09e+11. In the year 2008, what is the difference between the Expenses (in $) of Croatia and Expenses (in $) of Malta?
Your response must be concise. 9.50e+09. In the year 2008, what is the difference between the Expenses (in $) in Croatia and Expenses (in $) in Oman?
Your response must be concise. 2.74e+09. In the year 2008, what is the difference between the Expenses (in $) in Croatia and Expenses (in $) in Sweden?
Your answer should be compact. -1.13e+11. In the year 2008, what is the difference between the Expenses (in $) in Malta and Expenses (in $) in Oman?
Offer a very short reply. -6.75e+09. In the year 2008, what is the difference between the Expenses (in $) in Malta and Expenses (in $) in Sweden?
Provide a short and direct response. -1.23e+11. In the year 2008, what is the difference between the Expenses (in $) in Oman and Expenses (in $) in Sweden?
Offer a very short reply. -1.16e+11. In the year 2009, what is the difference between the Expenses (in $) of Croatia and Expenses (in $) of Malta?
Ensure brevity in your answer.  1.02e+1. In the year 2009, what is the difference between the Expenses (in $) of Croatia and Expenses (in $) of Oman?
Your answer should be very brief. 4.28e+09. In the year 2009, what is the difference between the Expenses (in $) of Croatia and Expenses (in $) of Sweden?
Provide a short and direct response. -1.03e+11. In the year 2009, what is the difference between the Expenses (in $) in Malta and Expenses (in $) in Oman?
Provide a succinct answer. -5.90e+09. In the year 2009, what is the difference between the Expenses (in $) in Malta and Expenses (in $) in Sweden?
Your answer should be compact. -1.13e+11. In the year 2009, what is the difference between the Expenses (in $) of Oman and Expenses (in $) of Sweden?
Offer a very short reply. -1.07e+11. In the year 2010, what is the difference between the Expenses (in $) of Croatia and Expenses (in $) of Malta?
Your response must be concise. 8.96e+09. In the year 2010, what is the difference between the Expenses (in $) in Croatia and Expenses (in $) in Oman?
Your answer should be very brief. 1.96e+09. In the year 2010, what is the difference between the Expenses (in $) in Croatia and Expenses (in $) in Sweden?
Ensure brevity in your answer.  -1.05e+11. In the year 2010, what is the difference between the Expenses (in $) in Malta and Expenses (in $) in Oman?
Give a very brief answer. -7.00e+09. In the year 2010, what is the difference between the Expenses (in $) in Malta and Expenses (in $) in Sweden?
Your answer should be compact. -1.14e+11. In the year 2010, what is the difference between the Expenses (in $) in Oman and Expenses (in $) in Sweden?
Provide a succinct answer. -1.07e+11. What is the ratio of the Expenses (in $) of Croatia in 2003 to that in 2004?
Provide a succinct answer. 0.71. What is the ratio of the Expenses (in $) of Malta in 2003 to that in 2004?
Offer a very short reply. 0.75. What is the ratio of the Expenses (in $) in Oman in 2003 to that in 2004?
Ensure brevity in your answer.  0.81. What is the ratio of the Expenses (in $) in Croatia in 2003 to that in 2005?
Your answer should be compact. 0.69. What is the ratio of the Expenses (in $) of Malta in 2003 to that in 2005?
Your answer should be compact. 0.66. What is the ratio of the Expenses (in $) of Oman in 2003 to that in 2005?
Give a very brief answer. 0.74. What is the ratio of the Expenses (in $) of Sweden in 2003 to that in 2005?
Give a very brief answer. 0.79. What is the ratio of the Expenses (in $) of Croatia in 2003 to that in 2006?
Your answer should be very brief. 0.68. What is the ratio of the Expenses (in $) in Malta in 2003 to that in 2006?
Offer a terse response. 0.67. What is the ratio of the Expenses (in $) in Oman in 2003 to that in 2006?
Provide a short and direct response. 0.67. What is the ratio of the Expenses (in $) in Sweden in 2003 to that in 2006?
Ensure brevity in your answer.  0.8. What is the ratio of the Expenses (in $) of Croatia in 2003 to that in 2007?
Make the answer very short. 0.46. What is the ratio of the Expenses (in $) of Malta in 2003 to that in 2007?
Your answer should be very brief. 0.86. What is the ratio of the Expenses (in $) of Oman in 2003 to that in 2007?
Your response must be concise. 0.58. What is the ratio of the Expenses (in $) of Sweden in 2003 to that in 2007?
Give a very brief answer. 0.67. What is the ratio of the Expenses (in $) of Croatia in 2003 to that in 2008?
Ensure brevity in your answer.  0.56. What is the ratio of the Expenses (in $) in Malta in 2003 to that in 2008?
Offer a very short reply. 1.84. What is the ratio of the Expenses (in $) in Oman in 2003 to that in 2008?
Your response must be concise. 0.44. What is the ratio of the Expenses (in $) in Sweden in 2003 to that in 2008?
Keep it short and to the point. 0.62. What is the ratio of the Expenses (in $) in Croatia in 2003 to that in 2009?
Your answer should be very brief. 0.52. What is the ratio of the Expenses (in $) in Malta in 2003 to that in 2009?
Your response must be concise. 2.07. What is the ratio of the Expenses (in $) in Oman in 2003 to that in 2009?
Make the answer very short. 0.51. What is the ratio of the Expenses (in $) in Sweden in 2003 to that in 2009?
Offer a very short reply. 0.67. What is the ratio of the Expenses (in $) in Croatia in 2003 to that in 2010?
Give a very brief answer. 0.59. What is the ratio of the Expenses (in $) in Malta in 2003 to that in 2010?
Provide a succinct answer. 1.6. What is the ratio of the Expenses (in $) in Oman in 2003 to that in 2010?
Give a very brief answer. 0.43. What is the ratio of the Expenses (in $) of Sweden in 2003 to that in 2010?
Provide a succinct answer. 0.67. What is the ratio of the Expenses (in $) in Croatia in 2004 to that in 2005?
Offer a terse response. 0.98. What is the ratio of the Expenses (in $) of Malta in 2004 to that in 2005?
Offer a very short reply. 0.87. What is the ratio of the Expenses (in $) in Oman in 2004 to that in 2005?
Your answer should be compact. 0.91. What is the ratio of the Expenses (in $) in Sweden in 2004 to that in 2005?
Your response must be concise. 0.79. What is the ratio of the Expenses (in $) in Croatia in 2004 to that in 2006?
Ensure brevity in your answer.  0.96. What is the ratio of the Expenses (in $) of Malta in 2004 to that in 2006?
Offer a terse response. 0.88. What is the ratio of the Expenses (in $) of Oman in 2004 to that in 2006?
Give a very brief answer. 0.83. What is the ratio of the Expenses (in $) of Sweden in 2004 to that in 2006?
Ensure brevity in your answer.  0.8. What is the ratio of the Expenses (in $) of Croatia in 2004 to that in 2007?
Your response must be concise. 0.65. What is the ratio of the Expenses (in $) in Malta in 2004 to that in 2007?
Ensure brevity in your answer.  1.15. What is the ratio of the Expenses (in $) in Oman in 2004 to that in 2007?
Provide a succinct answer. 0.71. What is the ratio of the Expenses (in $) of Sweden in 2004 to that in 2007?
Keep it short and to the point. 0.67. What is the ratio of the Expenses (in $) in Croatia in 2004 to that in 2008?
Ensure brevity in your answer.  0.79. What is the ratio of the Expenses (in $) in Malta in 2004 to that in 2008?
Offer a very short reply. 2.45. What is the ratio of the Expenses (in $) of Oman in 2004 to that in 2008?
Provide a succinct answer. 0.55. What is the ratio of the Expenses (in $) of Sweden in 2004 to that in 2008?
Keep it short and to the point. 0.62. What is the ratio of the Expenses (in $) of Croatia in 2004 to that in 2009?
Provide a succinct answer. 0.74. What is the ratio of the Expenses (in $) in Malta in 2004 to that in 2009?
Keep it short and to the point. 2.75. What is the ratio of the Expenses (in $) in Oman in 2004 to that in 2009?
Your answer should be very brief. 0.62. What is the ratio of the Expenses (in $) in Sweden in 2004 to that in 2009?
Give a very brief answer. 0.68. What is the ratio of the Expenses (in $) of Croatia in 2004 to that in 2010?
Ensure brevity in your answer.  0.83. What is the ratio of the Expenses (in $) of Malta in 2004 to that in 2010?
Provide a short and direct response. 2.12. What is the ratio of the Expenses (in $) of Oman in 2004 to that in 2010?
Your response must be concise. 0.52. What is the ratio of the Expenses (in $) of Sweden in 2004 to that in 2010?
Offer a very short reply. 0.67. What is the ratio of the Expenses (in $) in Croatia in 2005 to that in 2006?
Provide a short and direct response. 0.98. What is the ratio of the Expenses (in $) of Malta in 2005 to that in 2006?
Ensure brevity in your answer.  1.02. What is the ratio of the Expenses (in $) of Oman in 2005 to that in 2006?
Make the answer very short. 0.91. What is the ratio of the Expenses (in $) in Sweden in 2005 to that in 2006?
Offer a very short reply. 1.01. What is the ratio of the Expenses (in $) of Croatia in 2005 to that in 2007?
Ensure brevity in your answer.  0.66. What is the ratio of the Expenses (in $) of Malta in 2005 to that in 2007?
Your response must be concise. 1.32. What is the ratio of the Expenses (in $) in Oman in 2005 to that in 2007?
Provide a succinct answer. 0.78. What is the ratio of the Expenses (in $) of Sweden in 2005 to that in 2007?
Provide a short and direct response. 0.84. What is the ratio of the Expenses (in $) in Croatia in 2005 to that in 2008?
Ensure brevity in your answer.  0.81. What is the ratio of the Expenses (in $) of Malta in 2005 to that in 2008?
Your answer should be compact. 2.82. What is the ratio of the Expenses (in $) of Oman in 2005 to that in 2008?
Give a very brief answer. 0.6. What is the ratio of the Expenses (in $) of Sweden in 2005 to that in 2008?
Your answer should be very brief. 0.78. What is the ratio of the Expenses (in $) in Croatia in 2005 to that in 2009?
Ensure brevity in your answer.  0.76. What is the ratio of the Expenses (in $) in Malta in 2005 to that in 2009?
Provide a short and direct response. 3.16. What is the ratio of the Expenses (in $) in Oman in 2005 to that in 2009?
Offer a very short reply. 0.69. What is the ratio of the Expenses (in $) of Sweden in 2005 to that in 2009?
Offer a terse response. 0.85. What is the ratio of the Expenses (in $) of Croatia in 2005 to that in 2010?
Your response must be concise. 0.85. What is the ratio of the Expenses (in $) of Malta in 2005 to that in 2010?
Your answer should be very brief. 2.44. What is the ratio of the Expenses (in $) of Oman in 2005 to that in 2010?
Keep it short and to the point. 0.58. What is the ratio of the Expenses (in $) in Sweden in 2005 to that in 2010?
Your response must be concise. 0.85. What is the ratio of the Expenses (in $) of Croatia in 2006 to that in 2007?
Offer a terse response. 0.67. What is the ratio of the Expenses (in $) in Malta in 2006 to that in 2007?
Make the answer very short. 1.3. What is the ratio of the Expenses (in $) of Oman in 2006 to that in 2007?
Offer a very short reply. 0.86. What is the ratio of the Expenses (in $) in Sweden in 2006 to that in 2007?
Ensure brevity in your answer.  0.83. What is the ratio of the Expenses (in $) of Croatia in 2006 to that in 2008?
Keep it short and to the point. 0.82. What is the ratio of the Expenses (in $) in Malta in 2006 to that in 2008?
Offer a terse response. 2.77. What is the ratio of the Expenses (in $) of Oman in 2006 to that in 2008?
Offer a very short reply. 0.66. What is the ratio of the Expenses (in $) of Sweden in 2006 to that in 2008?
Your answer should be compact. 0.78. What is the ratio of the Expenses (in $) in Croatia in 2006 to that in 2009?
Keep it short and to the point. 0.77. What is the ratio of the Expenses (in $) in Malta in 2006 to that in 2009?
Offer a very short reply. 3.1. What is the ratio of the Expenses (in $) of Oman in 2006 to that in 2009?
Give a very brief answer. 0.76. What is the ratio of the Expenses (in $) of Sweden in 2006 to that in 2009?
Your answer should be compact. 0.84. What is the ratio of the Expenses (in $) of Croatia in 2006 to that in 2010?
Offer a terse response. 0.87. What is the ratio of the Expenses (in $) in Malta in 2006 to that in 2010?
Ensure brevity in your answer.  2.4. What is the ratio of the Expenses (in $) in Oman in 2006 to that in 2010?
Your answer should be very brief. 0.63. What is the ratio of the Expenses (in $) of Sweden in 2006 to that in 2010?
Offer a very short reply. 0.84. What is the ratio of the Expenses (in $) in Croatia in 2007 to that in 2008?
Provide a short and direct response. 1.22. What is the ratio of the Expenses (in $) in Malta in 2007 to that in 2008?
Make the answer very short. 2.13. What is the ratio of the Expenses (in $) of Oman in 2007 to that in 2008?
Your response must be concise. 0.77. What is the ratio of the Expenses (in $) of Sweden in 2007 to that in 2008?
Keep it short and to the point. 0.93. What is the ratio of the Expenses (in $) of Croatia in 2007 to that in 2009?
Offer a terse response. 1.15. What is the ratio of the Expenses (in $) in Malta in 2007 to that in 2009?
Offer a very short reply. 2.39. What is the ratio of the Expenses (in $) of Oman in 2007 to that in 2009?
Ensure brevity in your answer.  0.88. What is the ratio of the Expenses (in $) of Sweden in 2007 to that in 2009?
Provide a short and direct response. 1.01. What is the ratio of the Expenses (in $) in Croatia in 2007 to that in 2010?
Make the answer very short. 1.29. What is the ratio of the Expenses (in $) in Malta in 2007 to that in 2010?
Your answer should be very brief. 1.84. What is the ratio of the Expenses (in $) of Oman in 2007 to that in 2010?
Your response must be concise. 0.74. What is the ratio of the Expenses (in $) of Sweden in 2007 to that in 2010?
Ensure brevity in your answer.  1.01. What is the ratio of the Expenses (in $) in Croatia in 2008 to that in 2009?
Your response must be concise. 0.94. What is the ratio of the Expenses (in $) of Malta in 2008 to that in 2009?
Provide a short and direct response. 1.12. What is the ratio of the Expenses (in $) in Oman in 2008 to that in 2009?
Give a very brief answer. 1.14. What is the ratio of the Expenses (in $) of Sweden in 2008 to that in 2009?
Offer a terse response. 1.08. What is the ratio of the Expenses (in $) in Croatia in 2008 to that in 2010?
Ensure brevity in your answer.  1.05. What is the ratio of the Expenses (in $) of Malta in 2008 to that in 2010?
Provide a short and direct response. 0.87. What is the ratio of the Expenses (in $) in Oman in 2008 to that in 2010?
Your answer should be compact. 0.96. What is the ratio of the Expenses (in $) in Sweden in 2008 to that in 2010?
Your answer should be compact. 1.08. What is the ratio of the Expenses (in $) in Croatia in 2009 to that in 2010?
Make the answer very short. 1.12. What is the ratio of the Expenses (in $) of Malta in 2009 to that in 2010?
Keep it short and to the point. 0.77. What is the ratio of the Expenses (in $) of Oman in 2009 to that in 2010?
Provide a short and direct response. 0.84. What is the ratio of the Expenses (in $) in Sweden in 2009 to that in 2010?
Your response must be concise. 1. What is the difference between the highest and the second highest Expenses (in $) of Croatia?
Your response must be concise. 1.53e+09. What is the difference between the highest and the second highest Expenses (in $) in Malta?
Make the answer very short. 1.19e+07. What is the difference between the highest and the second highest Expenses (in $) of Oman?
Provide a short and direct response. 2.88e+08. What is the difference between the highest and the second highest Expenses (in $) of Sweden?
Your answer should be compact. 8.23e+09. What is the difference between the highest and the lowest Expenses (in $) in Croatia?
Offer a terse response. 6.50e+09. What is the difference between the highest and the lowest Expenses (in $) in Malta?
Give a very brief answer. 5.09e+08. What is the difference between the highest and the lowest Expenses (in $) of Oman?
Ensure brevity in your answer.  4.19e+09. What is the difference between the highest and the lowest Expenses (in $) of Sweden?
Make the answer very short. 4.64e+1. 